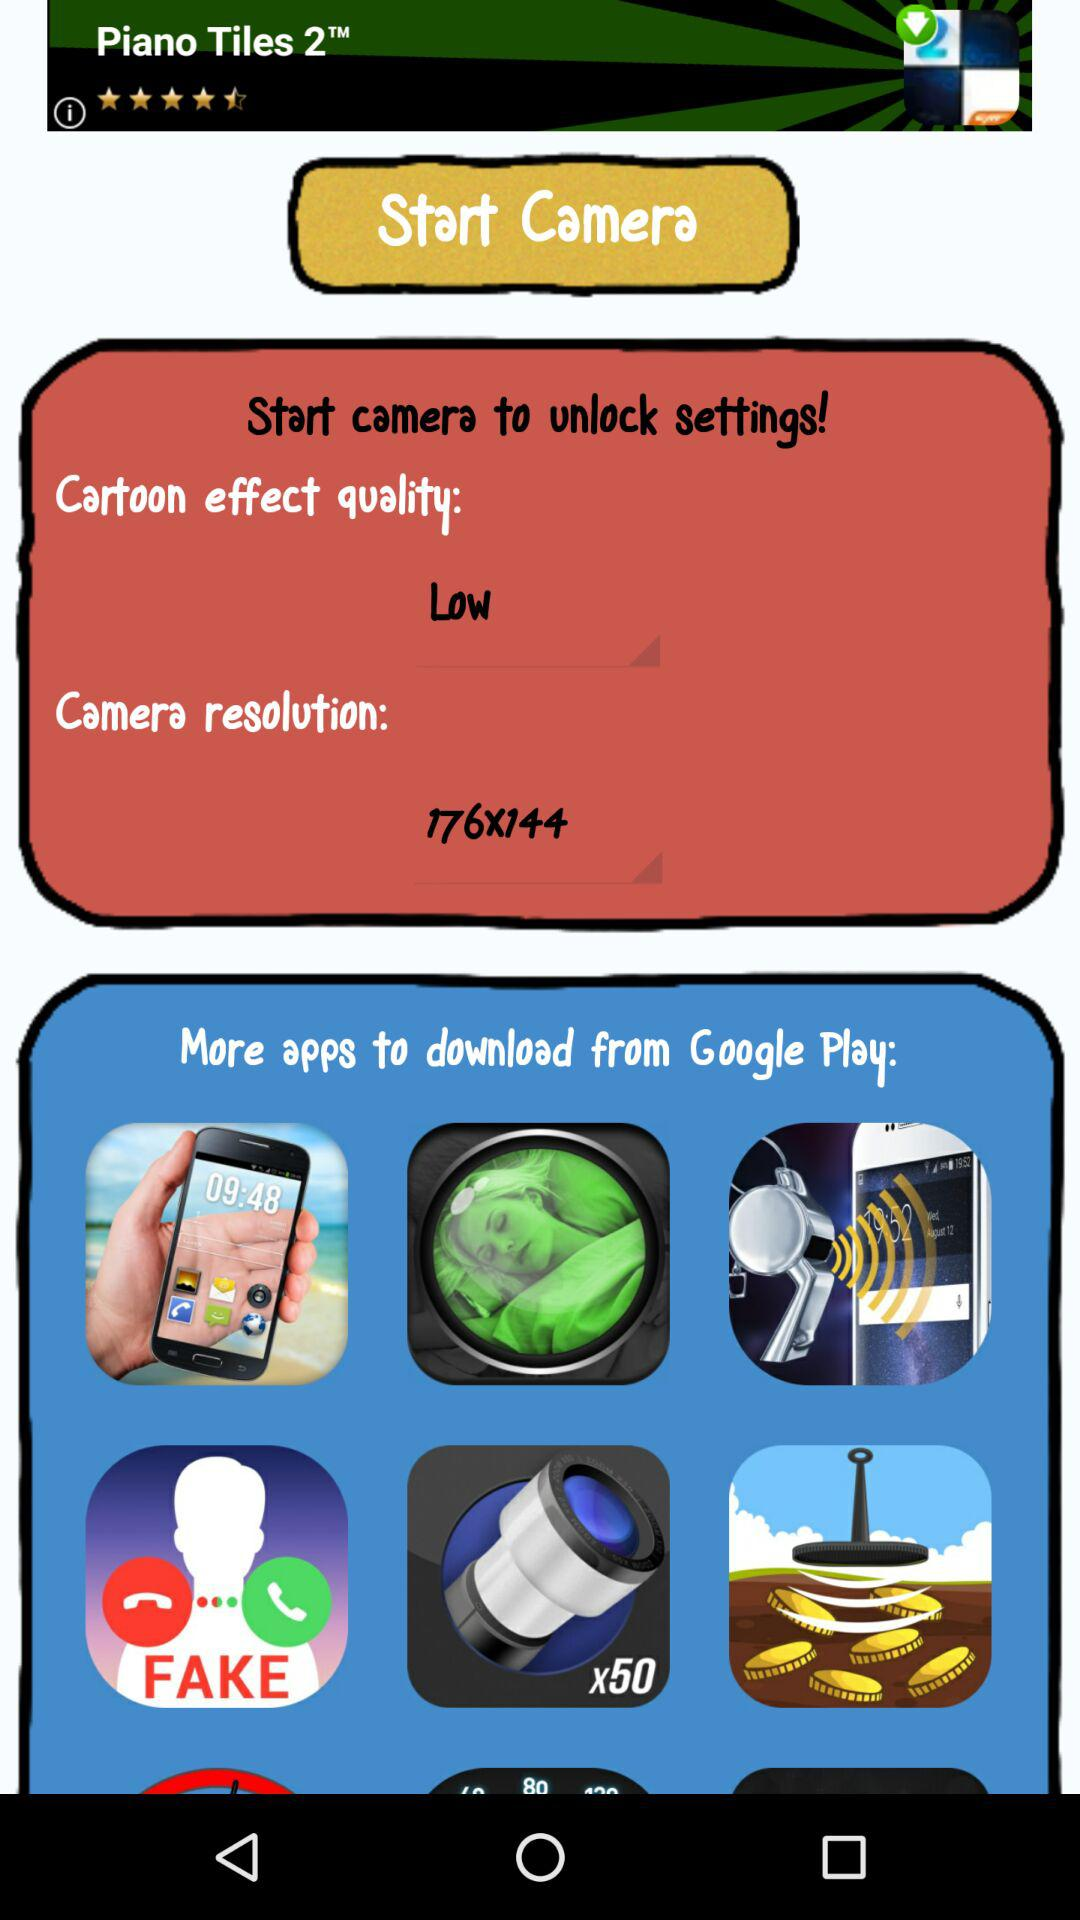What is the camera resolution? The camera resolution is 176X144. 